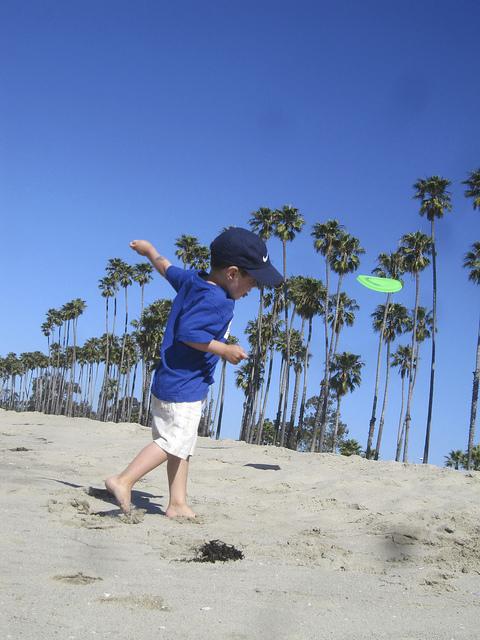What this photo probably taken in Africa?
Quick response, please. No. Where is the shore?
Short answer required. Behind boy. Could you expect rain?
Be succinct. No. What is flying?
Keep it brief. Frisbee. Is this man in a small town?
Quick response, please. No. Is the sky blue?
Answer briefly. Yes. Is this a wealthy area?
Keep it brief. Yes. Is this an airplane or kite?
Be succinct. Kite. Is it crowded?
Quick response, please. No. What letter is on the boy's hat?
Be succinct. 0. What are those objects in the sky?
Write a very short answer. Trees. What is this boy playing with?
Give a very brief answer. Frisbee. What color is the sand?
Quick response, please. White. Did he throw the disk?
Quick response, please. Yes. What is flying in the sky?
Be succinct. Frisbee. What color is the frisbee?
Be succinct. Green. Is it a windy day?
Be succinct. No. Is it night or day?
Give a very brief answer. Day. What is the ground made of?
Give a very brief answer. Sand. What is laying in the sand by the person's left hand?
Concise answer only. Seaweed. What species of palm tree is in the background?
Concise answer only. Palm. Is this person homeless?
Give a very brief answer. No. Is there an umbrella?
Answer briefly. No. What color is the boy's shirt?
Answer briefly. Blue. Do you assume this photo was taken during cold weather?
Keep it brief. No. 